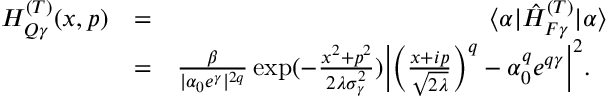Convert formula to latex. <formula><loc_0><loc_0><loc_500><loc_500>\begin{array} { r l r } { H _ { Q \gamma } ^ { ( T ) } ( x , p ) } & { = } & { \langle \alpha | \hat { H } _ { F \gamma } ^ { ( T ) } | \alpha \rangle } \\ & { = } & { \frac { \beta } { | \alpha _ { 0 } e ^ { \gamma } | ^ { 2 q } } \exp ( - \frac { x ^ { 2 } + p ^ { 2 } } { 2 \lambda \sigma _ { \gamma } ^ { 2 } } ) \left | \left ( \frac { x + i p } { \sqrt { 2 \lambda } } \right ) ^ { q } - \alpha _ { 0 } ^ { q } e ^ { q \gamma } \right | ^ { 2 } . \ \ } \end{array}</formula> 